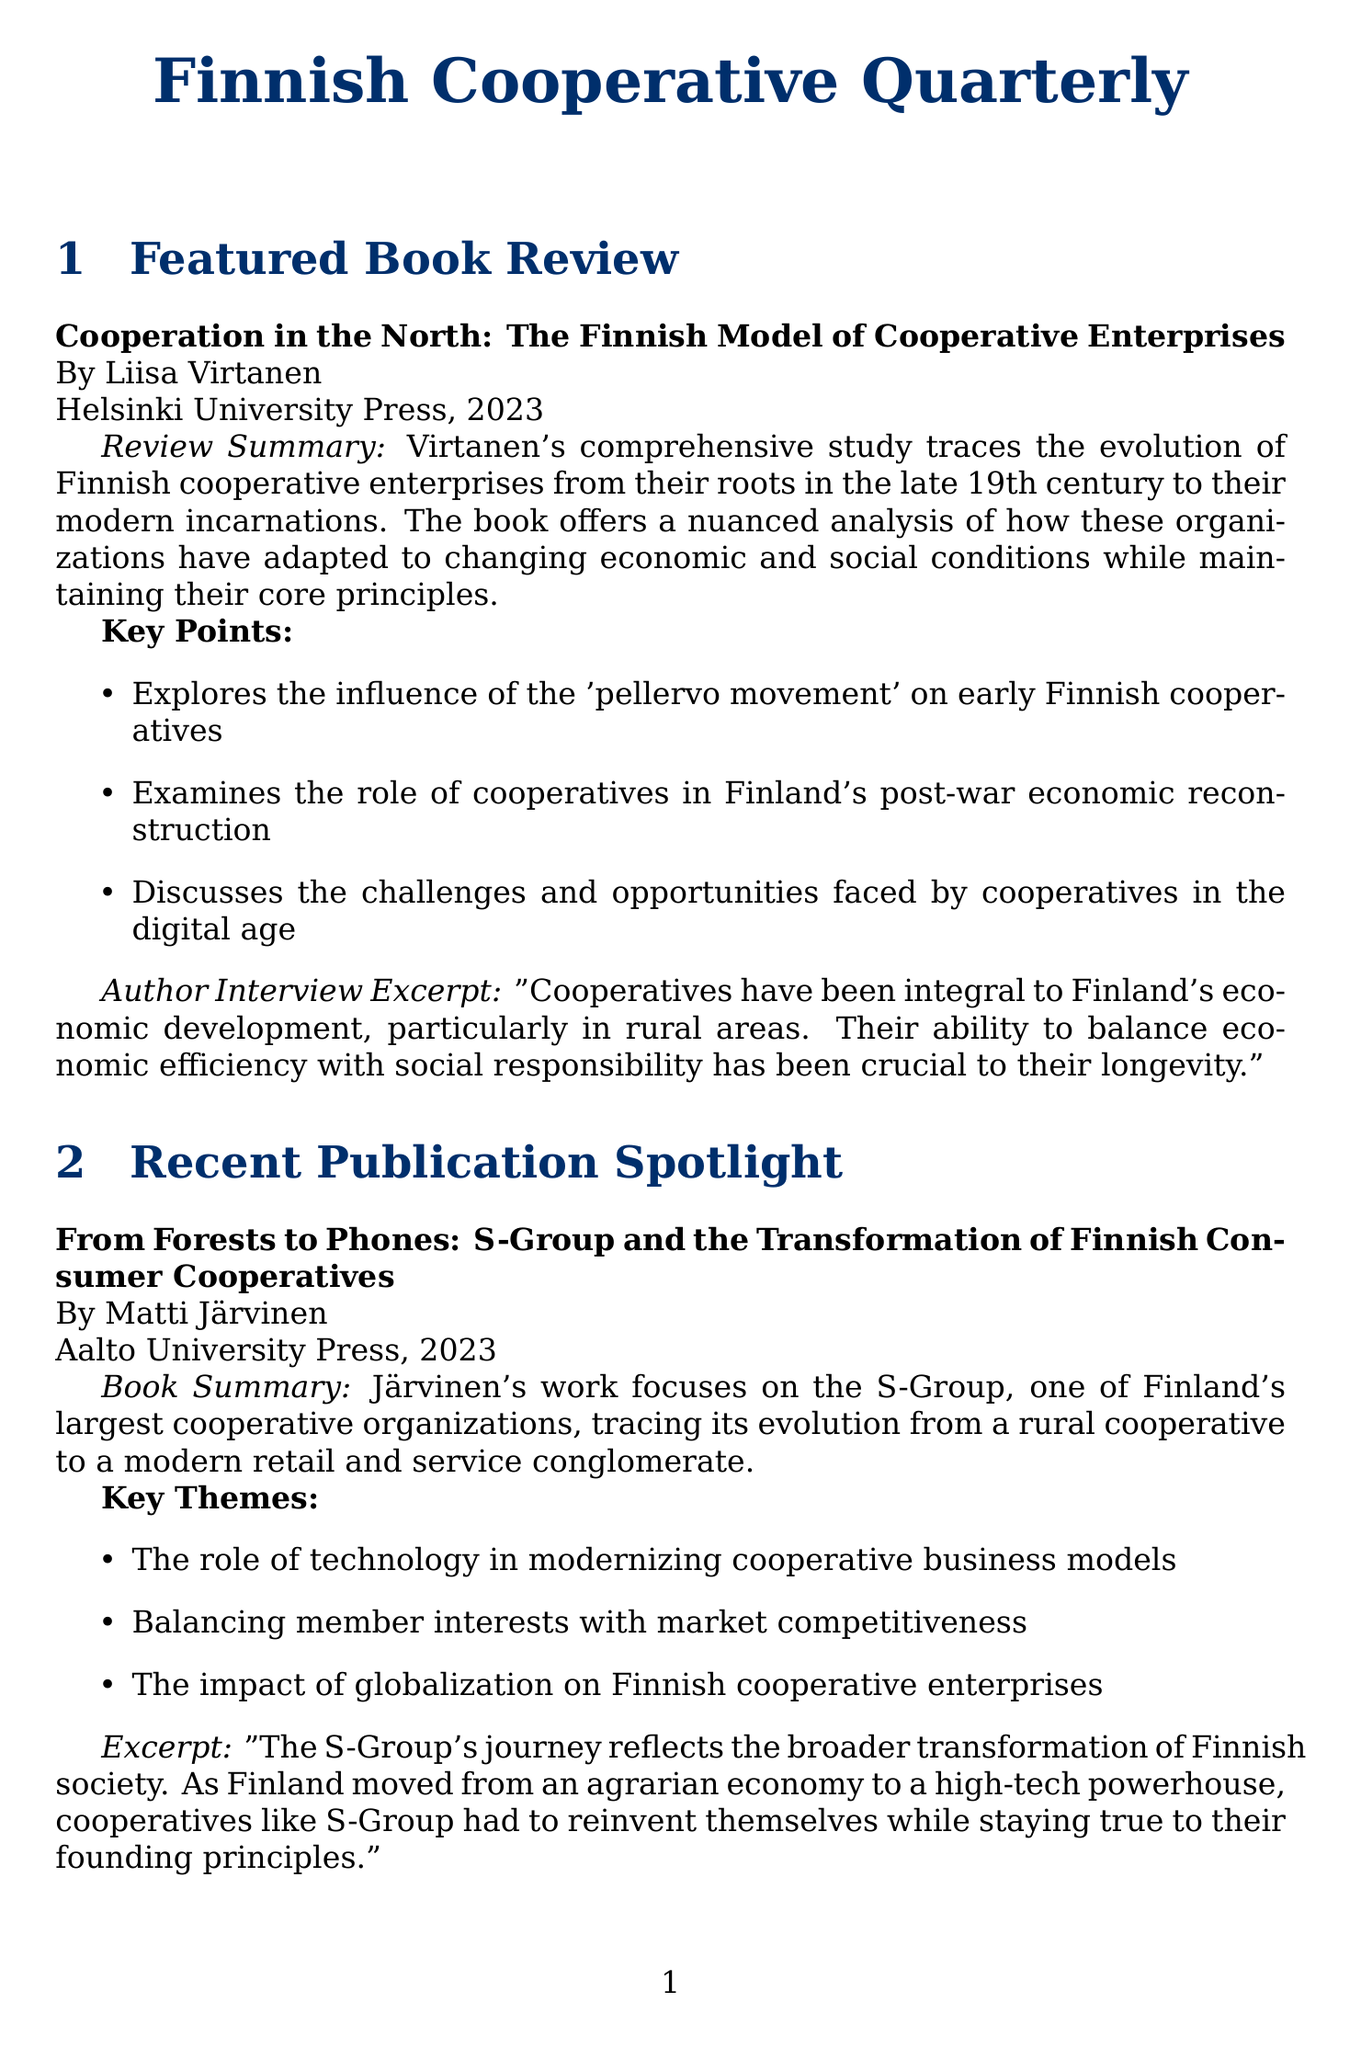What is the title of Liisa Virtanen's book? The title is explicitly mentioned in the "Featured Book Review" section as "Cooperation in the North: The Finnish Model of Cooperative Enterprises."
Answer: Cooperation in the North: The Finnish Model of Cooperative Enterprises Who is the author of "Cooperative Foundations"? The document identifies Anna-Maija Lehto as the author of "Cooperative Foundations."
Answer: Anna-Maija Lehto In what year was "From Forests to Phones" published? The publication year is stated in the "Recent Publication Spotlight" section, indicating it was published in 2023.
Answer: 2023 What key theme is discussed in Järvinen's book? The document lists key themes for Järvinen's book, including "The role of technology in modernizing cooperative business models."
Answer: The role of technology in modernizing cooperative business models What are Finnish cooperatives compared to in the comparative study? The relevance to Finland section describes how Finnish cooperatives can learn from "Nordic counterparts," highlighting comparisons with other Nordic countries.
Answer: Nordic counterparts What was emphasized by Hannes Gebhard according to Anna-Maija Lehto? The excerpt mentions Gebhard's emphasis on "education and rural development" as crucial for the cooperative movement.
Answer: education and rural development Which publisher released the book by Erik Magnusson and Johanna Nieminen? The publisher is mentioned in the "Comparative Study" section, indicating it was released by the Nordic Council of Ministers.
Answer: Nordic Council of Ministers 